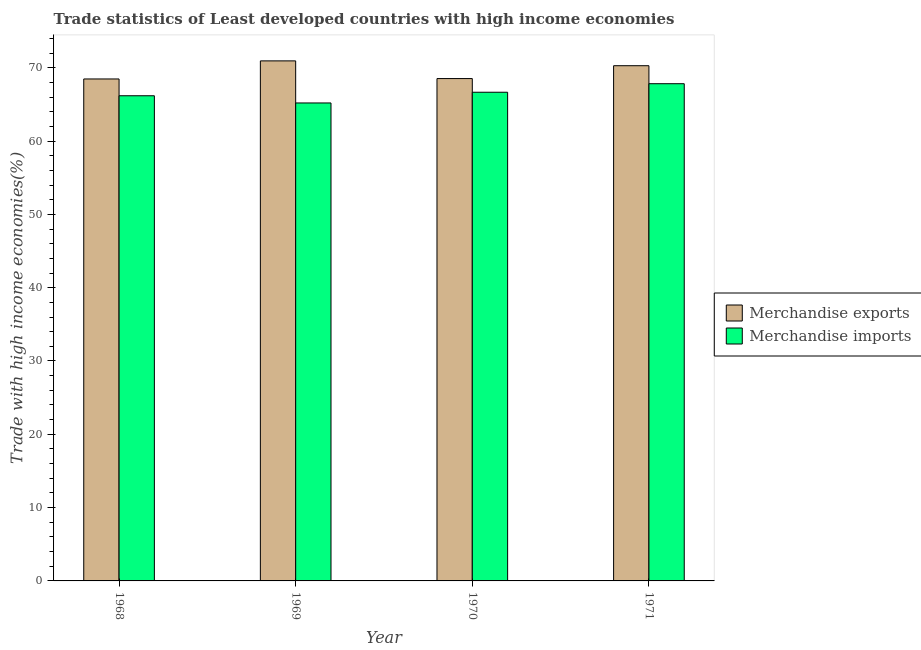How many different coloured bars are there?
Make the answer very short. 2. Are the number of bars per tick equal to the number of legend labels?
Provide a short and direct response. Yes. How many bars are there on the 1st tick from the left?
Make the answer very short. 2. How many bars are there on the 4th tick from the right?
Provide a short and direct response. 2. What is the label of the 4th group of bars from the left?
Offer a terse response. 1971. In how many cases, is the number of bars for a given year not equal to the number of legend labels?
Keep it short and to the point. 0. What is the merchandise imports in 1970?
Offer a very short reply. 66.66. Across all years, what is the maximum merchandise exports?
Provide a short and direct response. 70.94. Across all years, what is the minimum merchandise exports?
Make the answer very short. 68.47. In which year was the merchandise imports maximum?
Give a very brief answer. 1971. In which year was the merchandise exports minimum?
Keep it short and to the point. 1968. What is the total merchandise imports in the graph?
Your response must be concise. 265.86. What is the difference between the merchandise imports in 1970 and that in 1971?
Make the answer very short. -1.16. What is the difference between the merchandise exports in 1968 and the merchandise imports in 1970?
Your answer should be very brief. -0.05. What is the average merchandise imports per year?
Offer a terse response. 66.46. In the year 1969, what is the difference between the merchandise exports and merchandise imports?
Offer a very short reply. 0. In how many years, is the merchandise imports greater than 56 %?
Keep it short and to the point. 4. What is the ratio of the merchandise exports in 1968 to that in 1969?
Make the answer very short. 0.97. What is the difference between the highest and the second highest merchandise imports?
Keep it short and to the point. 1.16. What is the difference between the highest and the lowest merchandise exports?
Your answer should be compact. 2.47. In how many years, is the merchandise exports greater than the average merchandise exports taken over all years?
Give a very brief answer. 2. Is the sum of the merchandise exports in 1968 and 1971 greater than the maximum merchandise imports across all years?
Offer a very short reply. Yes. How many bars are there?
Keep it short and to the point. 8. Are all the bars in the graph horizontal?
Ensure brevity in your answer.  No. How many years are there in the graph?
Provide a succinct answer. 4. Does the graph contain grids?
Offer a very short reply. No. How many legend labels are there?
Offer a terse response. 2. What is the title of the graph?
Provide a succinct answer. Trade statistics of Least developed countries with high income economies. What is the label or title of the Y-axis?
Offer a terse response. Trade with high income economies(%). What is the Trade with high income economies(%) in Merchandise exports in 1968?
Provide a short and direct response. 68.47. What is the Trade with high income economies(%) of Merchandise imports in 1968?
Your answer should be compact. 66.18. What is the Trade with high income economies(%) of Merchandise exports in 1969?
Your response must be concise. 70.94. What is the Trade with high income economies(%) of Merchandise imports in 1969?
Provide a short and direct response. 65.2. What is the Trade with high income economies(%) of Merchandise exports in 1970?
Your answer should be very brief. 68.52. What is the Trade with high income economies(%) of Merchandise imports in 1970?
Give a very brief answer. 66.66. What is the Trade with high income economies(%) in Merchandise exports in 1971?
Make the answer very short. 70.28. What is the Trade with high income economies(%) in Merchandise imports in 1971?
Your answer should be compact. 67.82. Across all years, what is the maximum Trade with high income economies(%) in Merchandise exports?
Your answer should be very brief. 70.94. Across all years, what is the maximum Trade with high income economies(%) of Merchandise imports?
Make the answer very short. 67.82. Across all years, what is the minimum Trade with high income economies(%) in Merchandise exports?
Offer a terse response. 68.47. Across all years, what is the minimum Trade with high income economies(%) of Merchandise imports?
Give a very brief answer. 65.2. What is the total Trade with high income economies(%) in Merchandise exports in the graph?
Provide a short and direct response. 278.21. What is the total Trade with high income economies(%) of Merchandise imports in the graph?
Offer a terse response. 265.86. What is the difference between the Trade with high income economies(%) in Merchandise exports in 1968 and that in 1969?
Your answer should be compact. -2.47. What is the difference between the Trade with high income economies(%) of Merchandise imports in 1968 and that in 1969?
Keep it short and to the point. 0.98. What is the difference between the Trade with high income economies(%) of Merchandise exports in 1968 and that in 1970?
Provide a short and direct response. -0.05. What is the difference between the Trade with high income economies(%) in Merchandise imports in 1968 and that in 1970?
Give a very brief answer. -0.48. What is the difference between the Trade with high income economies(%) in Merchandise exports in 1968 and that in 1971?
Your answer should be compact. -1.81. What is the difference between the Trade with high income economies(%) of Merchandise imports in 1968 and that in 1971?
Ensure brevity in your answer.  -1.64. What is the difference between the Trade with high income economies(%) of Merchandise exports in 1969 and that in 1970?
Offer a terse response. 2.41. What is the difference between the Trade with high income economies(%) in Merchandise imports in 1969 and that in 1970?
Your answer should be compact. -1.46. What is the difference between the Trade with high income economies(%) of Merchandise exports in 1969 and that in 1971?
Provide a succinct answer. 0.66. What is the difference between the Trade with high income economies(%) of Merchandise imports in 1969 and that in 1971?
Offer a very short reply. -2.62. What is the difference between the Trade with high income economies(%) in Merchandise exports in 1970 and that in 1971?
Offer a very short reply. -1.75. What is the difference between the Trade with high income economies(%) of Merchandise imports in 1970 and that in 1971?
Offer a terse response. -1.16. What is the difference between the Trade with high income economies(%) of Merchandise exports in 1968 and the Trade with high income economies(%) of Merchandise imports in 1969?
Your answer should be compact. 3.27. What is the difference between the Trade with high income economies(%) of Merchandise exports in 1968 and the Trade with high income economies(%) of Merchandise imports in 1970?
Provide a succinct answer. 1.81. What is the difference between the Trade with high income economies(%) in Merchandise exports in 1968 and the Trade with high income economies(%) in Merchandise imports in 1971?
Offer a terse response. 0.65. What is the difference between the Trade with high income economies(%) of Merchandise exports in 1969 and the Trade with high income economies(%) of Merchandise imports in 1970?
Make the answer very short. 4.28. What is the difference between the Trade with high income economies(%) in Merchandise exports in 1969 and the Trade with high income economies(%) in Merchandise imports in 1971?
Offer a very short reply. 3.12. What is the difference between the Trade with high income economies(%) in Merchandise exports in 1970 and the Trade with high income economies(%) in Merchandise imports in 1971?
Provide a short and direct response. 0.7. What is the average Trade with high income economies(%) of Merchandise exports per year?
Your response must be concise. 69.55. What is the average Trade with high income economies(%) in Merchandise imports per year?
Offer a terse response. 66.46. In the year 1968, what is the difference between the Trade with high income economies(%) in Merchandise exports and Trade with high income economies(%) in Merchandise imports?
Your answer should be very brief. 2.29. In the year 1969, what is the difference between the Trade with high income economies(%) of Merchandise exports and Trade with high income economies(%) of Merchandise imports?
Provide a short and direct response. 5.74. In the year 1970, what is the difference between the Trade with high income economies(%) of Merchandise exports and Trade with high income economies(%) of Merchandise imports?
Provide a short and direct response. 1.86. In the year 1971, what is the difference between the Trade with high income economies(%) of Merchandise exports and Trade with high income economies(%) of Merchandise imports?
Your answer should be very brief. 2.46. What is the ratio of the Trade with high income economies(%) of Merchandise exports in 1968 to that in 1969?
Ensure brevity in your answer.  0.97. What is the ratio of the Trade with high income economies(%) in Merchandise imports in 1968 to that in 1969?
Provide a short and direct response. 1.02. What is the ratio of the Trade with high income economies(%) of Merchandise exports in 1968 to that in 1970?
Offer a terse response. 1. What is the ratio of the Trade with high income economies(%) in Merchandise exports in 1968 to that in 1971?
Your answer should be very brief. 0.97. What is the ratio of the Trade with high income economies(%) of Merchandise imports in 1968 to that in 1971?
Ensure brevity in your answer.  0.98. What is the ratio of the Trade with high income economies(%) of Merchandise exports in 1969 to that in 1970?
Provide a succinct answer. 1.04. What is the ratio of the Trade with high income economies(%) in Merchandise imports in 1969 to that in 1970?
Offer a terse response. 0.98. What is the ratio of the Trade with high income economies(%) in Merchandise exports in 1969 to that in 1971?
Offer a terse response. 1.01. What is the ratio of the Trade with high income economies(%) in Merchandise imports in 1969 to that in 1971?
Offer a very short reply. 0.96. What is the ratio of the Trade with high income economies(%) in Merchandise imports in 1970 to that in 1971?
Offer a terse response. 0.98. What is the difference between the highest and the second highest Trade with high income economies(%) of Merchandise exports?
Provide a succinct answer. 0.66. What is the difference between the highest and the second highest Trade with high income economies(%) of Merchandise imports?
Offer a very short reply. 1.16. What is the difference between the highest and the lowest Trade with high income economies(%) of Merchandise exports?
Ensure brevity in your answer.  2.47. What is the difference between the highest and the lowest Trade with high income economies(%) of Merchandise imports?
Provide a short and direct response. 2.62. 